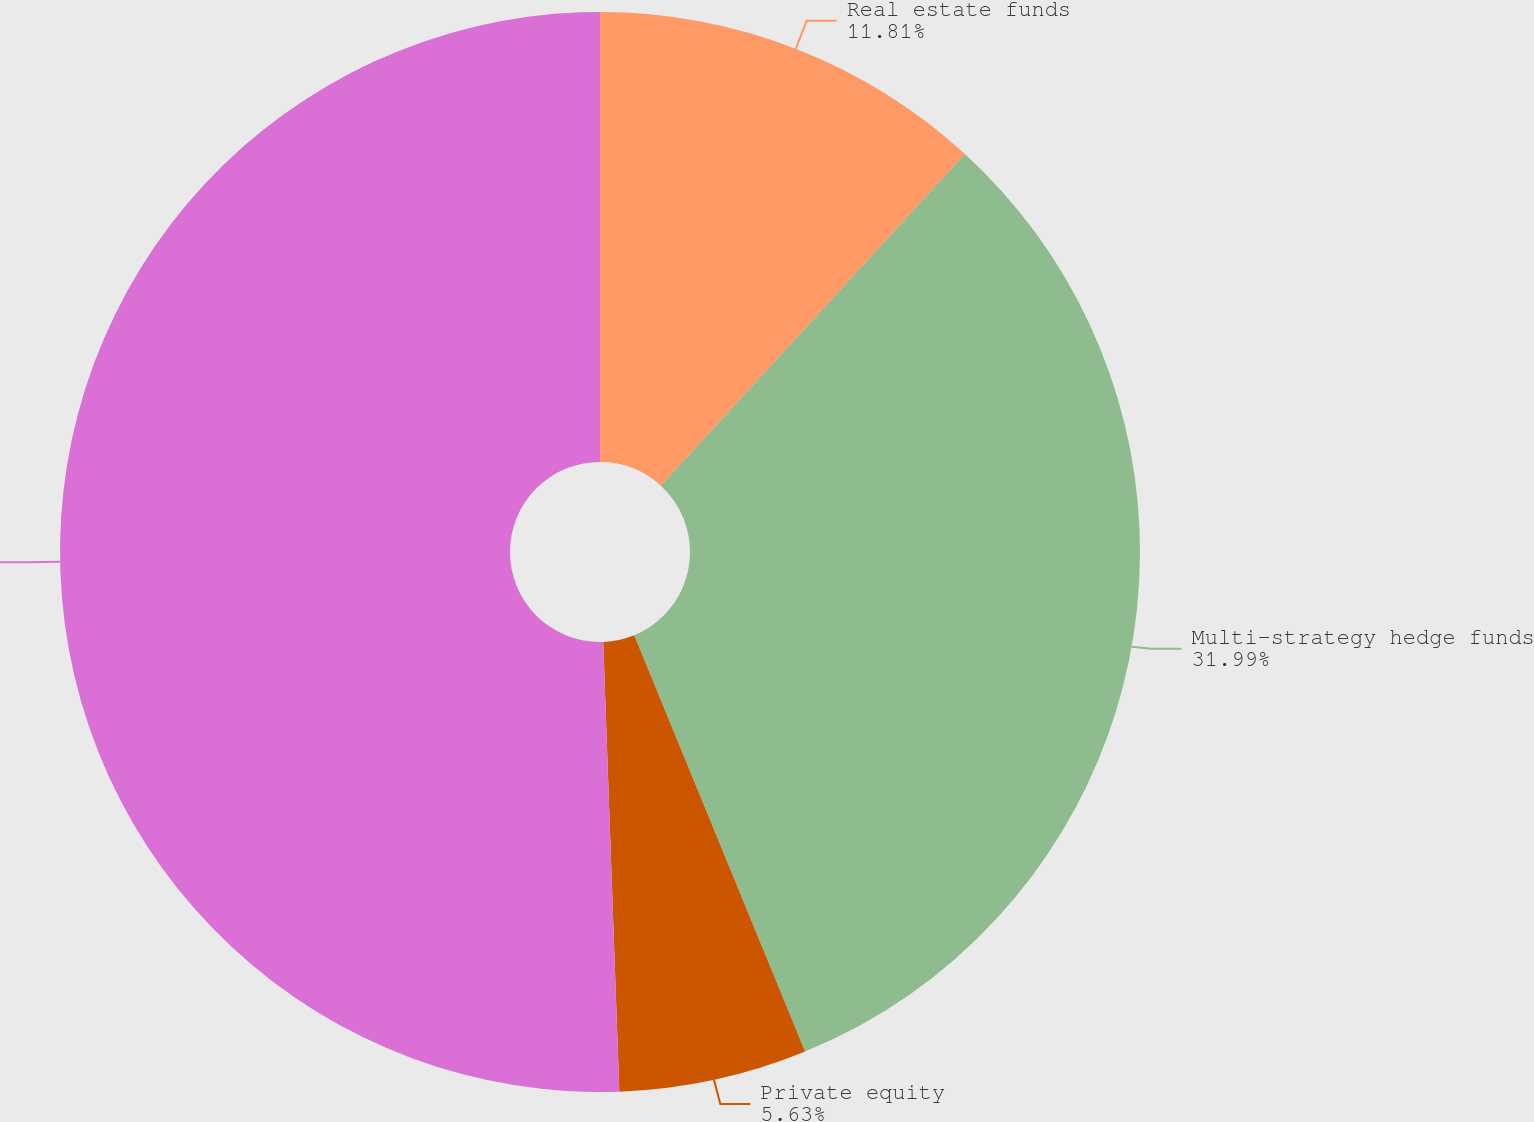<chart> <loc_0><loc_0><loc_500><loc_500><pie_chart><fcel>Real estate funds<fcel>Multi-strategy hedge funds<fcel>Private equity<fcel>Total<nl><fcel>11.81%<fcel>31.99%<fcel>5.63%<fcel>50.57%<nl></chart> 